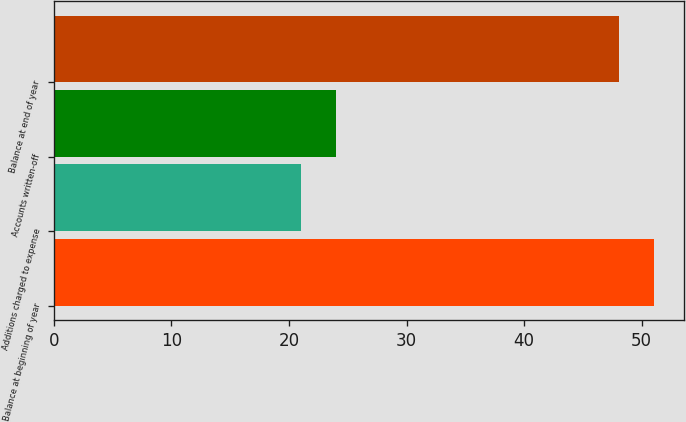<chart> <loc_0><loc_0><loc_500><loc_500><bar_chart><fcel>Balance at beginning of year<fcel>Additions charged to expense<fcel>Accounts written-off<fcel>Balance at end of year<nl><fcel>51.09<fcel>21<fcel>23.99<fcel>48.1<nl></chart> 